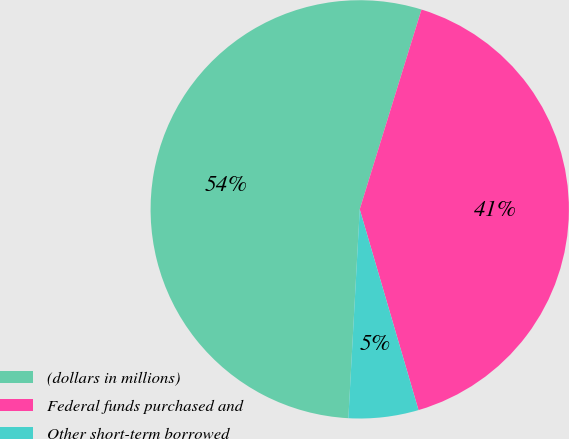Convert chart. <chart><loc_0><loc_0><loc_500><loc_500><pie_chart><fcel>(dollars in millions)<fcel>Federal funds purchased and<fcel>Other short-term borrowed<nl><fcel>53.91%<fcel>40.7%<fcel>5.4%<nl></chart> 